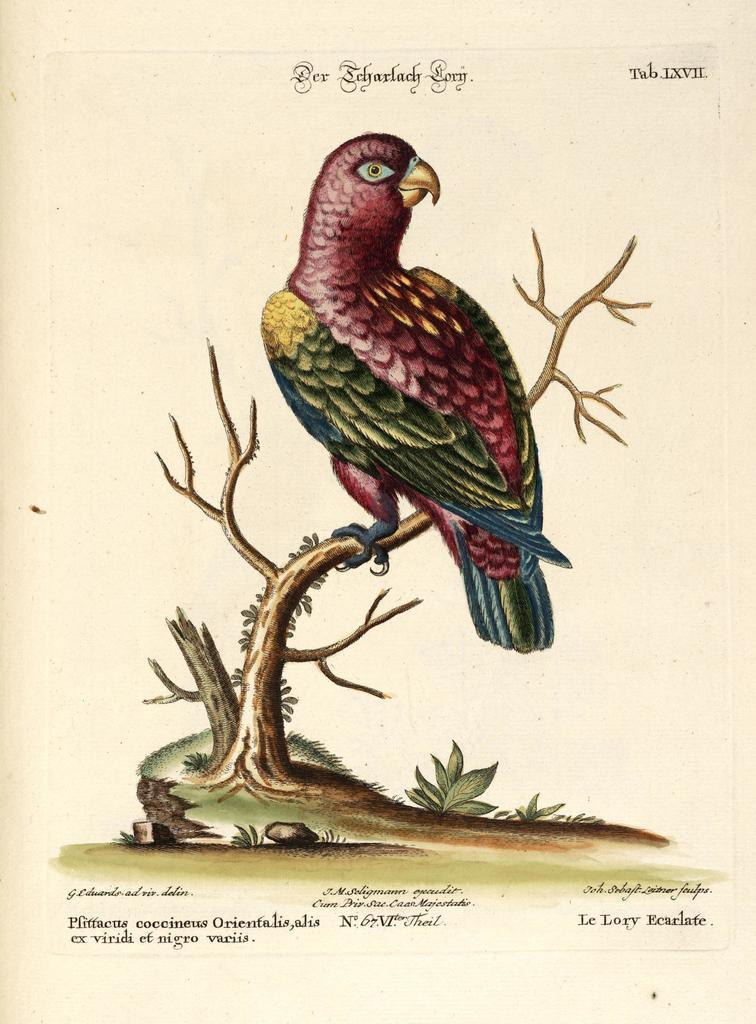What is featured on the poster in the image? The poster contains a bird on a tree. What else can be seen on the poster besides the bird and tree? There is text on the poster. How many quilts are hanging on the tree in the image? There are no quilts present in the image; the poster features a bird on a tree. What type of horn is visible on the bird in the image? There is no horn present on the bird in the image; it is a bird on a tree. 